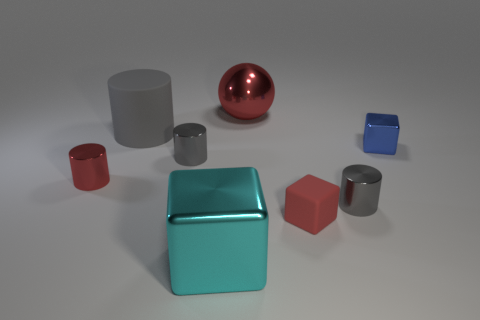Is there a large cyan thing that has the same shape as the big gray object?
Provide a short and direct response. No. Is the number of large cyan metallic things less than the number of tiny gray things?
Your answer should be compact. Yes. Is the small blue metallic object the same shape as the cyan object?
Ensure brevity in your answer.  Yes. How many objects are rubber blocks or rubber things to the right of the big cyan shiny cube?
Provide a short and direct response. 1. How many tiny red cylinders are there?
Keep it short and to the point. 1. Is there a gray rubber thing that has the same size as the red metallic cylinder?
Give a very brief answer. No. Is the number of tiny metal cylinders that are on the left side of the tiny red matte thing less than the number of big cyan metallic things?
Provide a succinct answer. No. Does the blue block have the same size as the gray rubber cylinder?
Offer a very short reply. No. There is a red sphere that is the same material as the large block; what is its size?
Provide a short and direct response. Large. What number of small metallic cylinders have the same color as the big matte cylinder?
Provide a short and direct response. 2. 